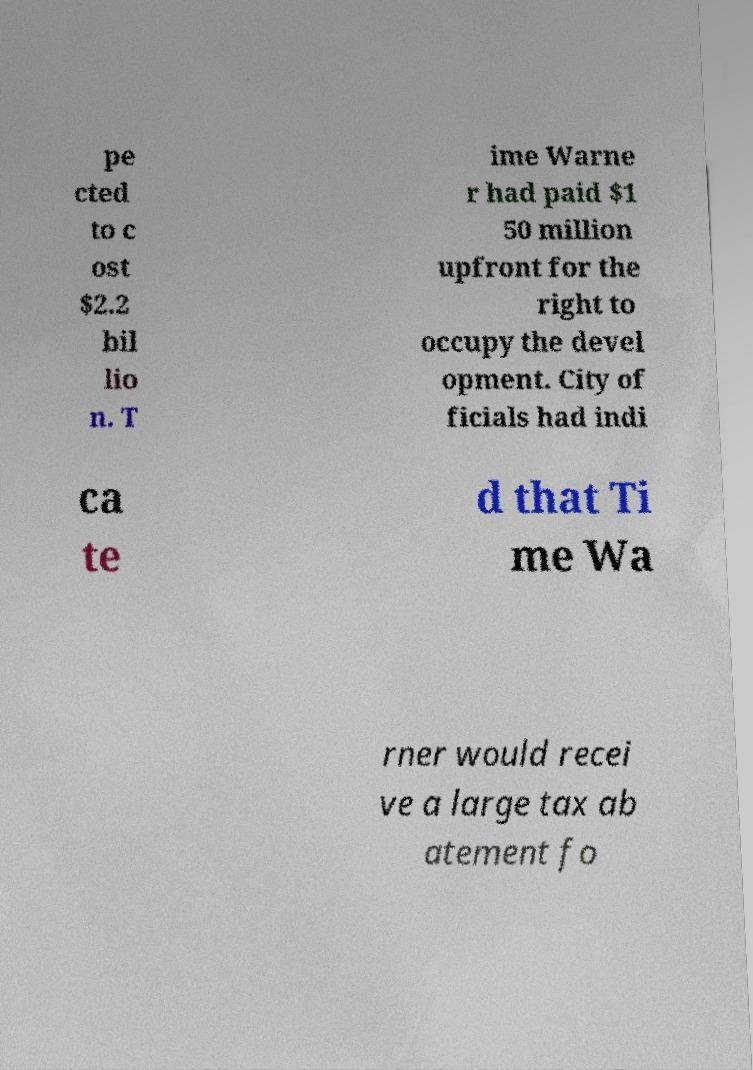Could you assist in decoding the text presented in this image and type it out clearly? pe cted to c ost $2.2 bil lio n. T ime Warne r had paid $1 50 million upfront for the right to occupy the devel opment. City of ficials had indi ca te d that Ti me Wa rner would recei ve a large tax ab atement fo 